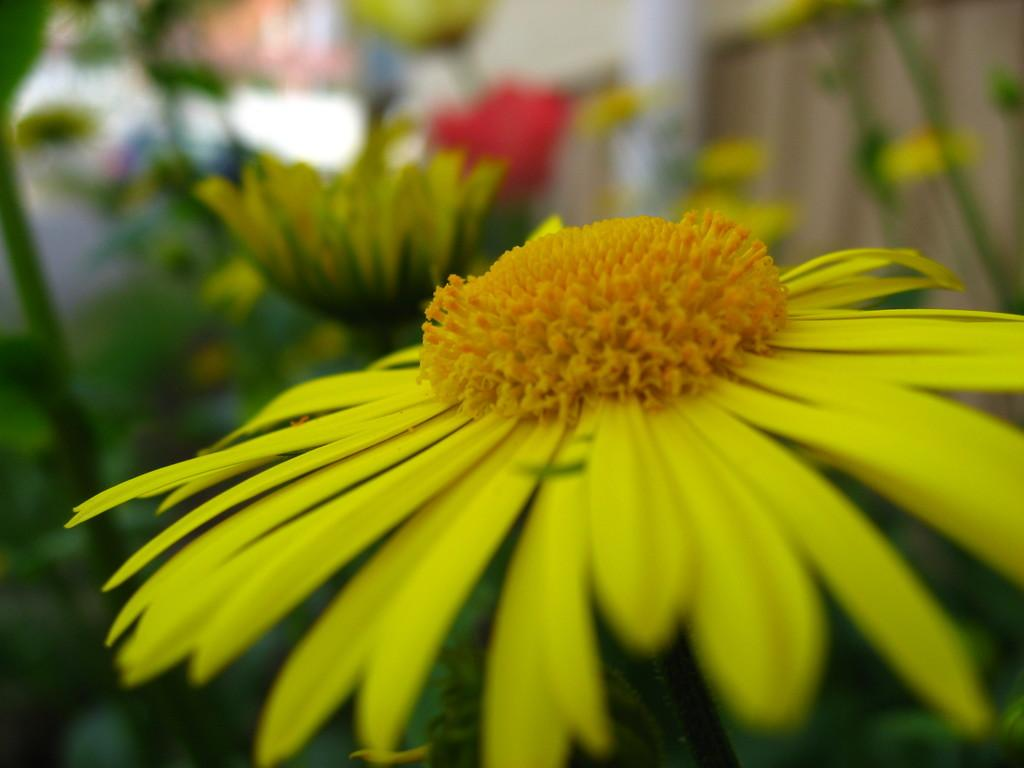What is the main subject of the picture? There is a flower in the middle of the picture. Can you describe the background of the image? The background of the image is blurred. What type of news can be heard coming from the quill in the image? There is no quill present in the image, and therefore no news can be heard from it. 